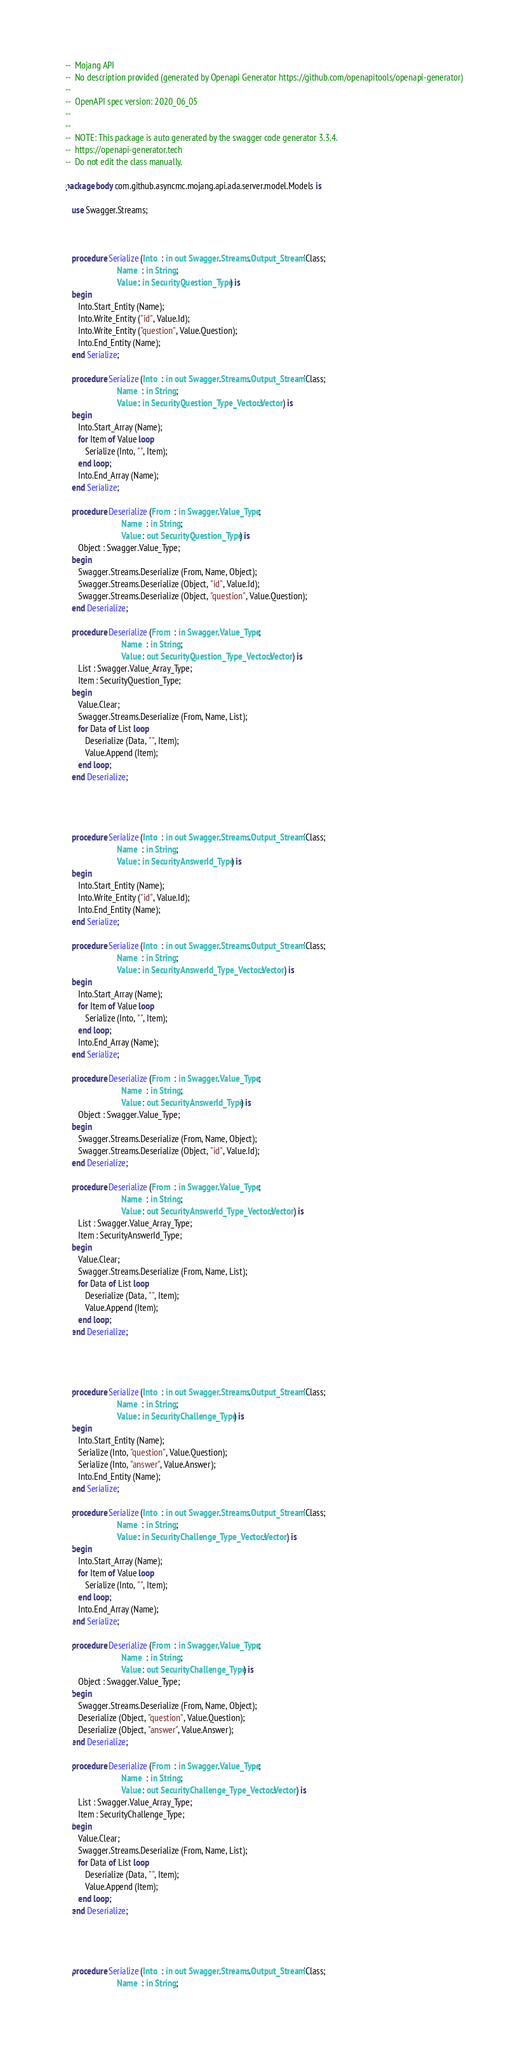Convert code to text. <code><loc_0><loc_0><loc_500><loc_500><_Ada_>--  Mojang API
--  No description provided (generated by Openapi Generator https://github.com/openapitools/openapi-generator)
--
--  OpenAPI spec version: 2020_06_05
--  
--
--  NOTE: This package is auto generated by the swagger code generator 3.3.4.
--  https://openapi-generator.tech
--  Do not edit the class manually.

package body com.github.asyncmc.mojang.api.ada.server.model.Models is

   use Swagger.Streams;



   procedure Serialize (Into  : in out Swagger.Streams.Output_Stream'Class;
                        Name  : in String;
                        Value : in SecurityQuestion_Type) is
   begin
      Into.Start_Entity (Name);
      Into.Write_Entity ("id", Value.Id);
      Into.Write_Entity ("question", Value.Question);
      Into.End_Entity (Name);
   end Serialize;

   procedure Serialize (Into  : in out Swagger.Streams.Output_Stream'Class;
                        Name  : in String;
                        Value : in SecurityQuestion_Type_Vectors.Vector) is
   begin
      Into.Start_Array (Name);
      for Item of Value loop
         Serialize (Into, "", Item);
      end loop;
      Into.End_Array (Name);
   end Serialize;

   procedure Deserialize (From  : in Swagger.Value_Type;
                          Name  : in String;
                          Value : out SecurityQuestion_Type) is
      Object : Swagger.Value_Type;
   begin
      Swagger.Streams.Deserialize (From, Name, Object);
      Swagger.Streams.Deserialize (Object, "id", Value.Id);
      Swagger.Streams.Deserialize (Object, "question", Value.Question);
   end Deserialize;

   procedure Deserialize (From  : in Swagger.Value_Type;
                          Name  : in String;
                          Value : out SecurityQuestion_Type_Vectors.Vector) is
      List : Swagger.Value_Array_Type;
      Item : SecurityQuestion_Type;
   begin
      Value.Clear;
      Swagger.Streams.Deserialize (From, Name, List);
      for Data of List loop
         Deserialize (Data, "", Item);
         Value.Append (Item);
      end loop;
   end Deserialize;




   procedure Serialize (Into  : in out Swagger.Streams.Output_Stream'Class;
                        Name  : in String;
                        Value : in SecurityAnswerId_Type) is
   begin
      Into.Start_Entity (Name);
      Into.Write_Entity ("id", Value.Id);
      Into.End_Entity (Name);
   end Serialize;

   procedure Serialize (Into  : in out Swagger.Streams.Output_Stream'Class;
                        Name  : in String;
                        Value : in SecurityAnswerId_Type_Vectors.Vector) is
   begin
      Into.Start_Array (Name);
      for Item of Value loop
         Serialize (Into, "", Item);
      end loop;
      Into.End_Array (Name);
   end Serialize;

   procedure Deserialize (From  : in Swagger.Value_Type;
                          Name  : in String;
                          Value : out SecurityAnswerId_Type) is
      Object : Swagger.Value_Type;
   begin
      Swagger.Streams.Deserialize (From, Name, Object);
      Swagger.Streams.Deserialize (Object, "id", Value.Id);
   end Deserialize;

   procedure Deserialize (From  : in Swagger.Value_Type;
                          Name  : in String;
                          Value : out SecurityAnswerId_Type_Vectors.Vector) is
      List : Swagger.Value_Array_Type;
      Item : SecurityAnswerId_Type;
   begin
      Value.Clear;
      Swagger.Streams.Deserialize (From, Name, List);
      for Data of List loop
         Deserialize (Data, "", Item);
         Value.Append (Item);
      end loop;
   end Deserialize;




   procedure Serialize (Into  : in out Swagger.Streams.Output_Stream'Class;
                        Name  : in String;
                        Value : in SecurityChallenge_Type) is
   begin
      Into.Start_Entity (Name);
      Serialize (Into, "question", Value.Question);
      Serialize (Into, "answer", Value.Answer);
      Into.End_Entity (Name);
   end Serialize;

   procedure Serialize (Into  : in out Swagger.Streams.Output_Stream'Class;
                        Name  : in String;
                        Value : in SecurityChallenge_Type_Vectors.Vector) is
   begin
      Into.Start_Array (Name);
      for Item of Value loop
         Serialize (Into, "", Item);
      end loop;
      Into.End_Array (Name);
   end Serialize;

   procedure Deserialize (From  : in Swagger.Value_Type;
                          Name  : in String;
                          Value : out SecurityChallenge_Type) is
      Object : Swagger.Value_Type;
   begin
      Swagger.Streams.Deserialize (From, Name, Object);
      Deserialize (Object, "question", Value.Question);
      Deserialize (Object, "answer", Value.Answer);
   end Deserialize;

   procedure Deserialize (From  : in Swagger.Value_Type;
                          Name  : in String;
                          Value : out SecurityChallenge_Type_Vectors.Vector) is
      List : Swagger.Value_Array_Type;
      Item : SecurityChallenge_Type;
   begin
      Value.Clear;
      Swagger.Streams.Deserialize (From, Name, List);
      for Data of List loop
         Deserialize (Data, "", Item);
         Value.Append (Item);
      end loop;
   end Deserialize;




   procedure Serialize (Into  : in out Swagger.Streams.Output_Stream'Class;
                        Name  : in String;</code> 